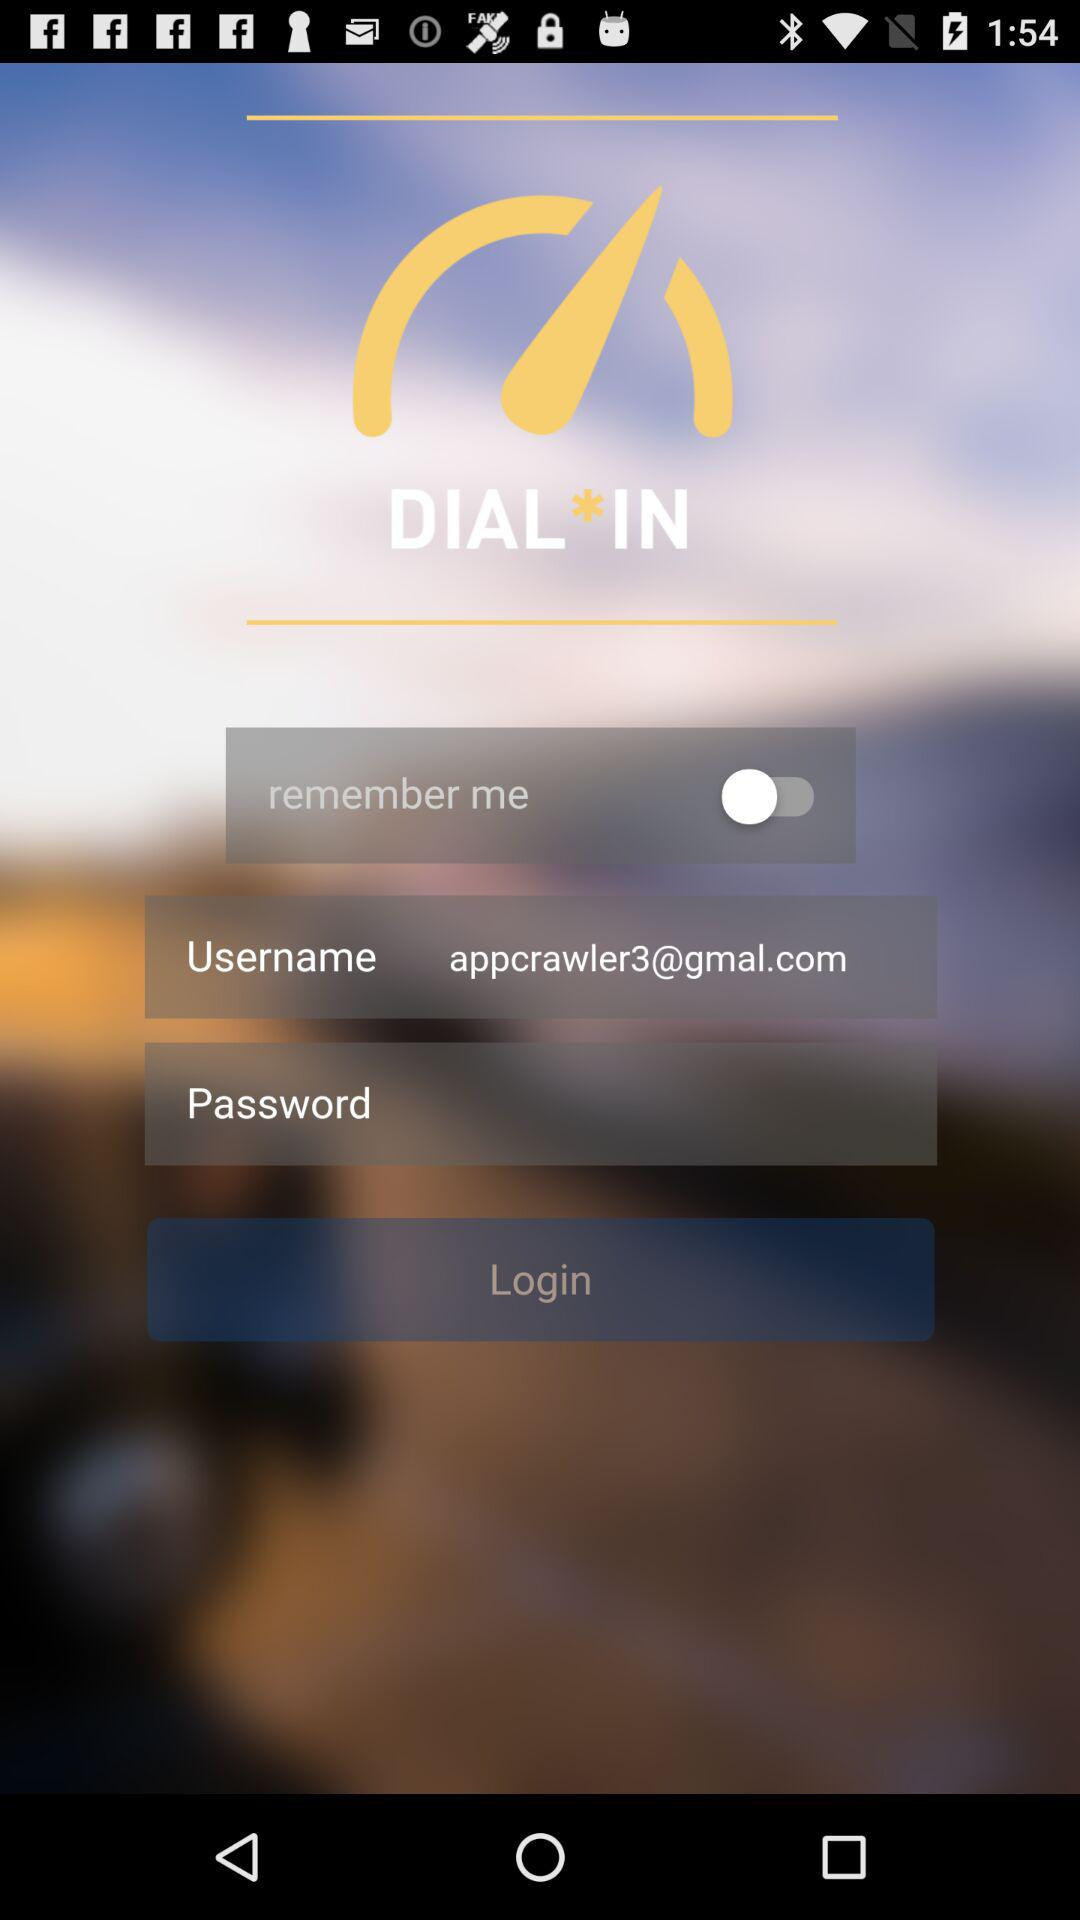What is the email address? The email address is appcrawler3@gmal.com. 